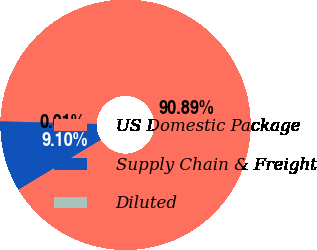Convert chart. <chart><loc_0><loc_0><loc_500><loc_500><pie_chart><fcel>US Domestic Package<fcel>Supply Chain & Freight<fcel>Diluted<nl><fcel>90.89%<fcel>9.1%<fcel>0.01%<nl></chart> 